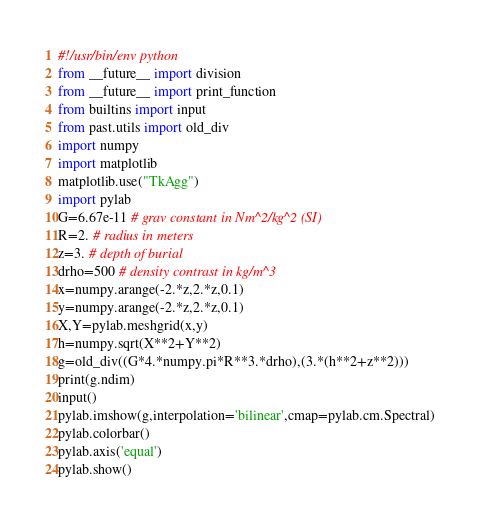<code> <loc_0><loc_0><loc_500><loc_500><_Python_>#!/usr/bin/env python
from __future__ import division
from __future__ import print_function
from builtins import input
from past.utils import old_div
import numpy
import matplotlib
matplotlib.use("TkAgg")
import pylab
G=6.67e-11 # grav constant in Nm^2/kg^2 (SI)
R=2. # radius in meters
z=3. # depth of burial
drho=500 # density contrast in kg/m^3
x=numpy.arange(-2.*z,2.*z,0.1)
y=numpy.arange(-2.*z,2.*z,0.1)
X,Y=pylab.meshgrid(x,y)
h=numpy.sqrt(X**2+Y**2)
g=old_div((G*4.*numpy.pi*R**3.*drho),(3.*(h**2+z**2)))
print(g.ndim)
input()
pylab.imshow(g,interpolation='bilinear',cmap=pylab.cm.Spectral)
pylab.colorbar()
pylab.axis('equal')
pylab.show()
</code> 